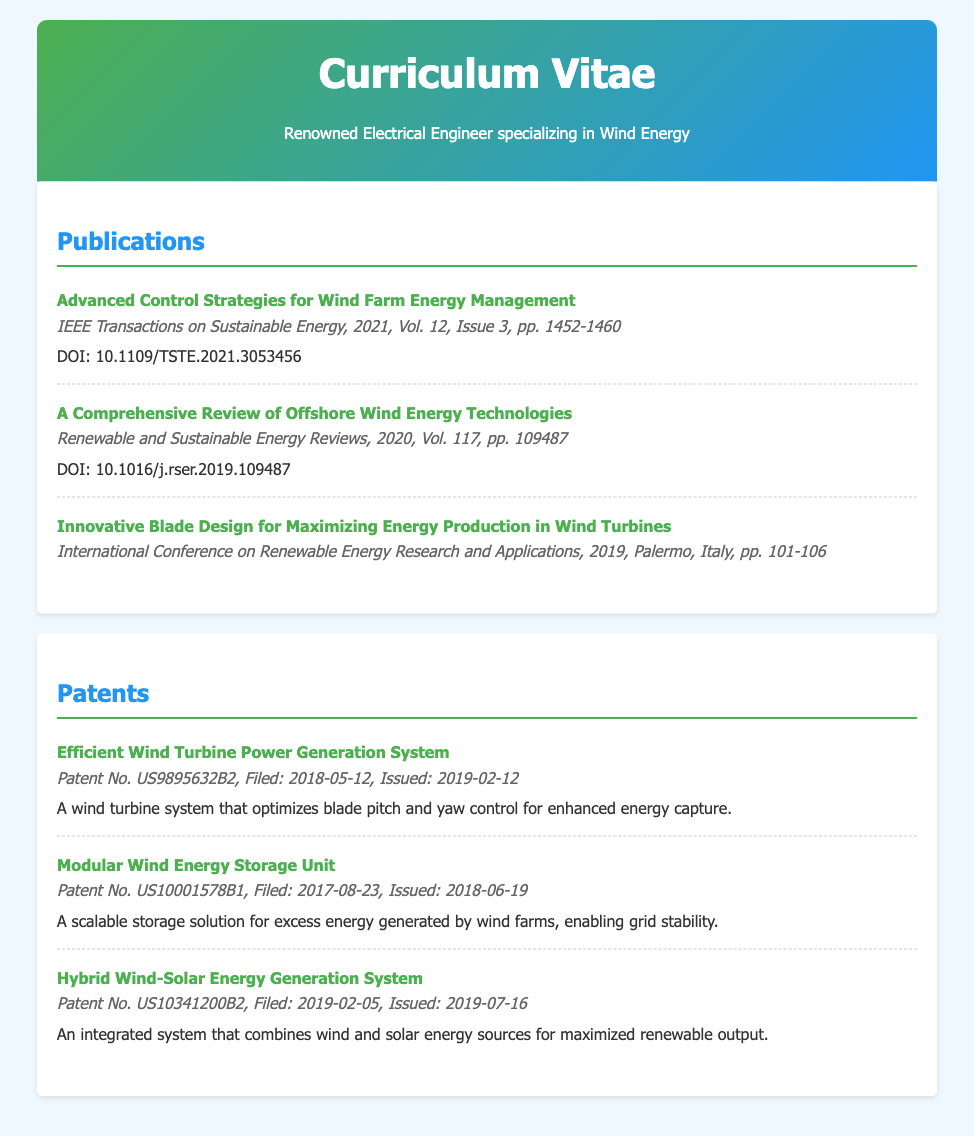What is the title of the publication discussing wind farm energy management? The title is mentioned prominently at the beginning of the publication section, specifically addressing energy management in wind farms.
Answer: Advanced Control Strategies for Wind Farm Energy Management Which journal published the comprehensive review on offshore wind energy technologies? The journal is specified for the respective publication, focusing on reviews related to renewable and sustainable energy.
Answer: Renewable and Sustainable Energy Reviews In which year was the patent for the Efficient Wind Turbine Power Generation System issued? The issuance date for this patent is provided in the details section, highlighting the timeline of patents.
Answer: 2019 How many publications are listed in the document? The total number of publications is counted from the entries provided in the publications section.
Answer: 3 What is the patent number for the Modular Wind Energy Storage Unit? The patent number is clearly stated in the details section of the patents, providing unique identification.
Answer: US10001578B1 Which conference hosted the presentation of the paper on innovative blade design? The conference name is shared within the publication details, indicating the event where the paper was presented.
Answer: International Conference on Renewable Energy Research and Applications What is the summary of the Hybrid Wind-Solar Energy Generation System patent? The summary encapsulates the main idea of the patent, detailing its innovative technology.
Answer: An integrated system that combines wind and solar energy sources for maximized renewable output What volume and issue of the IEEE Transactions on Sustainable Energy contains the publication on wind farm energy management? The volume and issue are provided in the details, indicating the specific publication source.
Answer: Vol. 12, Issue 3 